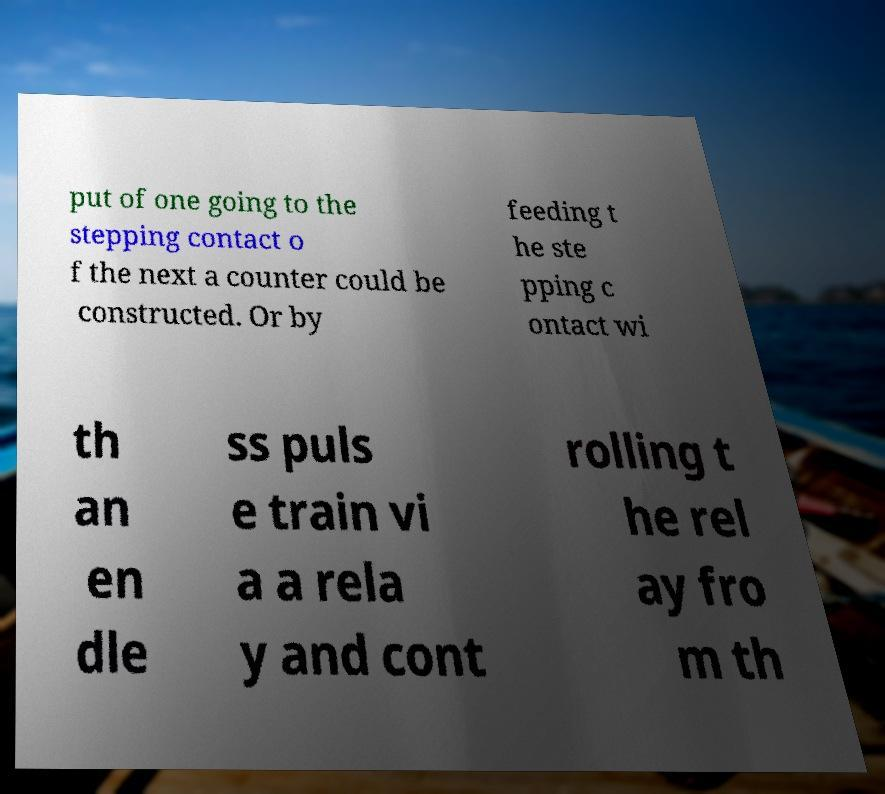For documentation purposes, I need the text within this image transcribed. Could you provide that? put of one going to the stepping contact o f the next a counter could be constructed. Or by feeding t he ste pping c ontact wi th an en dle ss puls e train vi a a rela y and cont rolling t he rel ay fro m th 